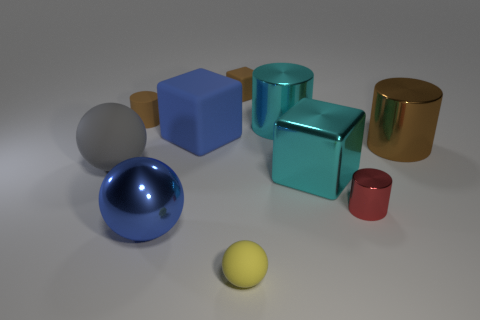How many tiny blue matte cylinders are there?
Offer a very short reply. 0. What number of small cylinders are both to the left of the big blue matte thing and to the right of the cyan cylinder?
Offer a terse response. 0. What is the material of the big blue block?
Your answer should be compact. Rubber. Is there a big gray metal sphere?
Provide a short and direct response. No. There is a tiny rubber object that is in front of the blue metallic ball; what is its color?
Keep it short and to the point. Yellow. There is a large blue object that is behind the large ball on the left side of the tiny brown matte cylinder; how many tiny yellow rubber balls are to the left of it?
Ensure brevity in your answer.  0. There is a small thing that is both left of the small matte block and on the right side of the brown rubber cylinder; what material is it?
Your response must be concise. Rubber. Are the blue cube and the big block on the right side of the yellow matte thing made of the same material?
Keep it short and to the point. No. Are there more tiny rubber objects that are in front of the big gray matte thing than big shiny blocks on the left side of the large cyan shiny block?
Ensure brevity in your answer.  Yes. What shape is the blue matte object?
Offer a very short reply. Cube. 